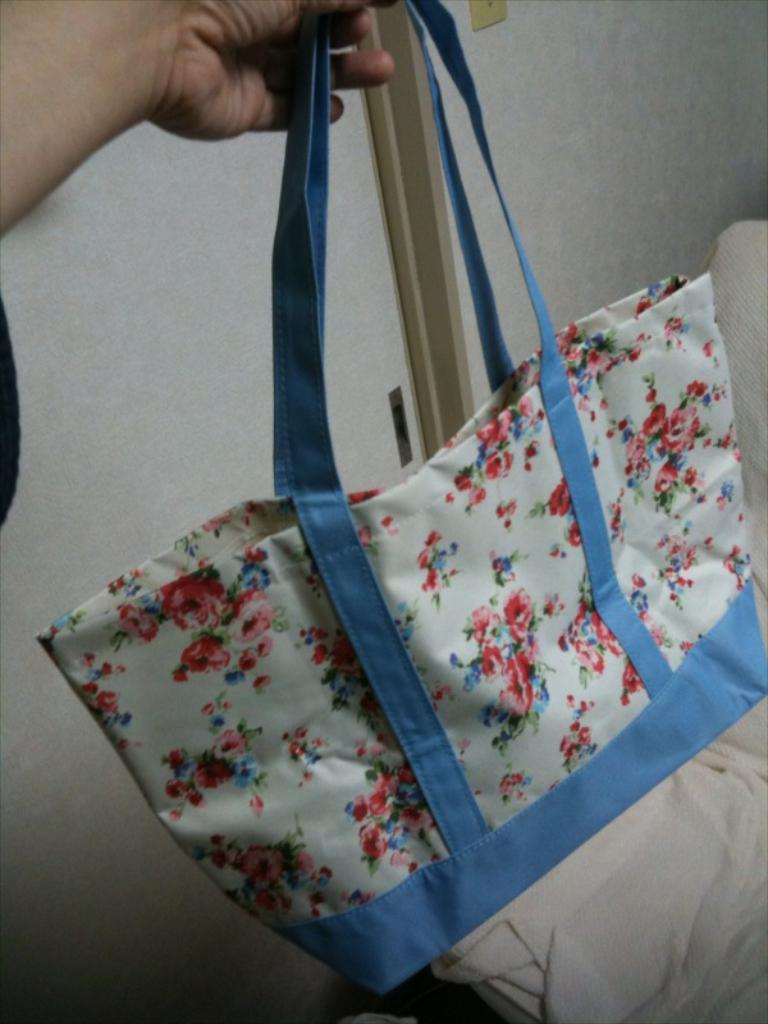Who or what is present in the image? There is a person in the image. What is the person holding in the image? The person is holding a bag. How does the person appear to be holding the bag? The person appears to be holding the bag with ease. What can be seen in the background of the image? There is a wall and cloth visible in the background of the image. What company is the person representing in the image? There is no indication of a company or any affiliation in the image. Can you tell me how many times the person jumps in the image? There is no jumping or any such action depicted in the image. 